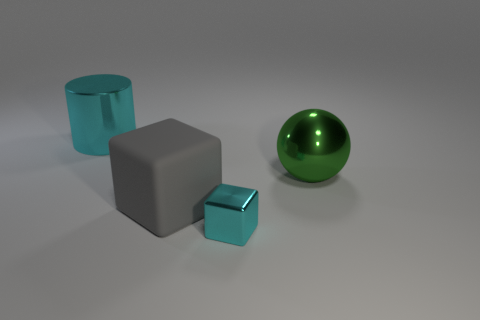Is there anything else that has the same size as the cyan cube?
Make the answer very short. No. Do the cylinder and the small shiny block have the same color?
Your response must be concise. Yes. What number of large metal things are both on the right side of the small block and behind the green object?
Offer a very short reply. 0. What is the shape of the green thing that is the same size as the metal cylinder?
Provide a succinct answer. Sphere. There is a tiny thing on the right side of the cyan metallic object on the left side of the small metallic object; are there any cyan metal things in front of it?
Give a very brief answer. No. There is a metal block; does it have the same color as the big metal object left of the sphere?
Offer a terse response. Yes. What number of cylinders have the same color as the small block?
Give a very brief answer. 1. There is a cyan metallic thing behind the large metal thing that is to the right of the small cyan metallic cube; what is its size?
Your answer should be compact. Large. What number of objects are big gray cubes left of the small metallic block or big yellow rubber spheres?
Give a very brief answer. 1. Is there a cyan cylinder of the same size as the gray thing?
Offer a very short reply. Yes. 